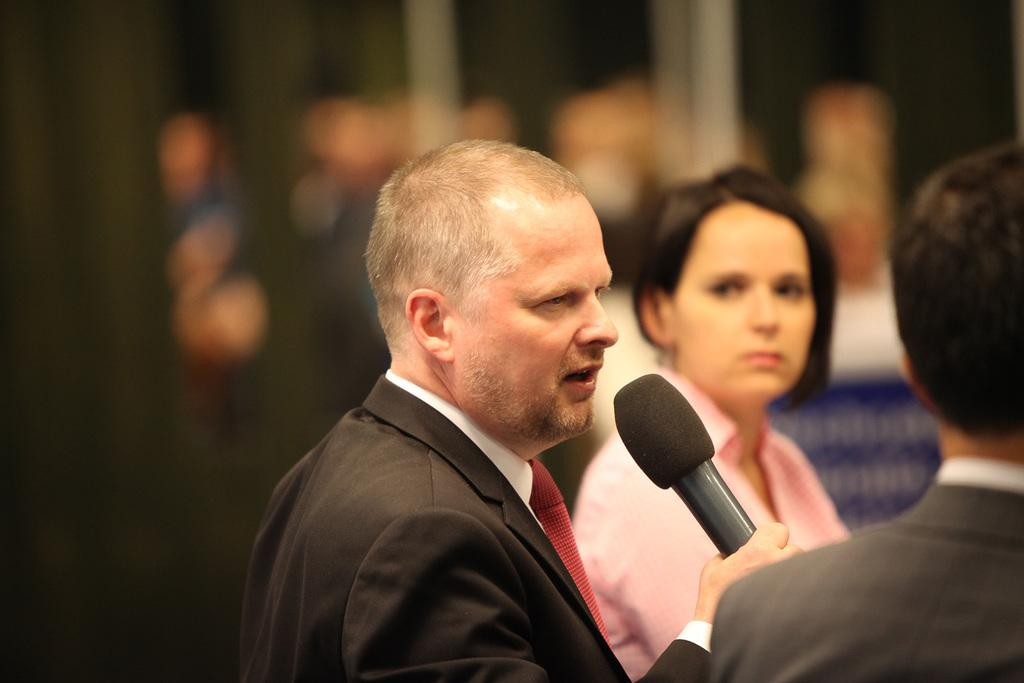What is the man in the image holding? The man is holding a microphone. Who else is present in the image besides the man? There is a woman and another person in the image. What might the man be doing with the microphone? The man might be using the microphone for speaking or singing. What type of lumber is being used to construct the religious building in the image? There is no religious building or lumber present in the image. How does the moon appear in the image? There is no moon visible in the image. 